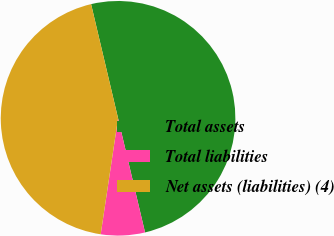Convert chart. <chart><loc_0><loc_0><loc_500><loc_500><pie_chart><fcel>Total assets<fcel>Total liabilities<fcel>Net assets (liabilities) (4)<nl><fcel>50.0%<fcel>6.06%<fcel>43.94%<nl></chart> 